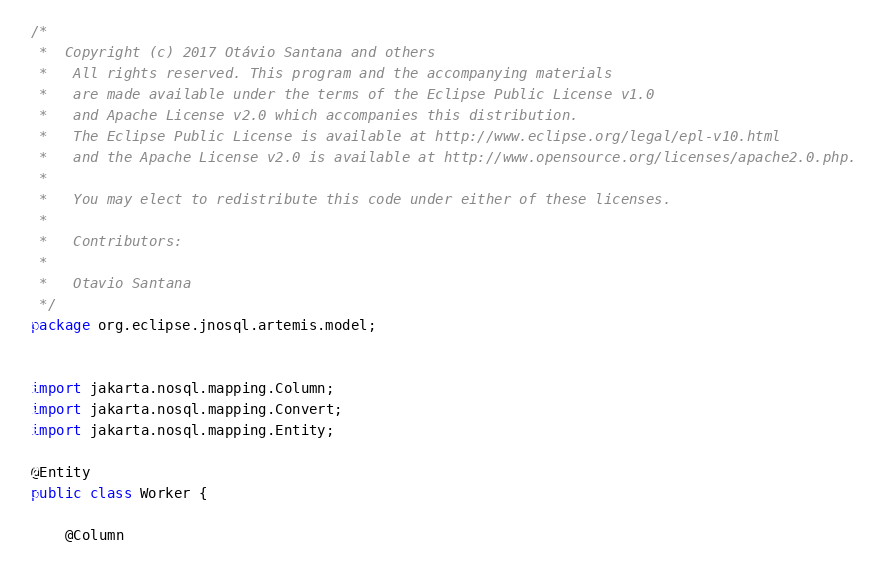Convert code to text. <code><loc_0><loc_0><loc_500><loc_500><_Java_>/*
 *  Copyright (c) 2017 Otávio Santana and others
 *   All rights reserved. This program and the accompanying materials
 *   are made available under the terms of the Eclipse Public License v1.0
 *   and Apache License v2.0 which accompanies this distribution.
 *   The Eclipse Public License is available at http://www.eclipse.org/legal/epl-v10.html
 *   and the Apache License v2.0 is available at http://www.opensource.org/licenses/apache2.0.php.
 *
 *   You may elect to redistribute this code under either of these licenses.
 *
 *   Contributors:
 *
 *   Otavio Santana
 */
package org.eclipse.jnosql.artemis.model;


import jakarta.nosql.mapping.Column;
import jakarta.nosql.mapping.Convert;
import jakarta.nosql.mapping.Entity;

@Entity
public class Worker {

    @Column</code> 